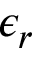Convert formula to latex. <formula><loc_0><loc_0><loc_500><loc_500>\epsilon _ { r }</formula> 